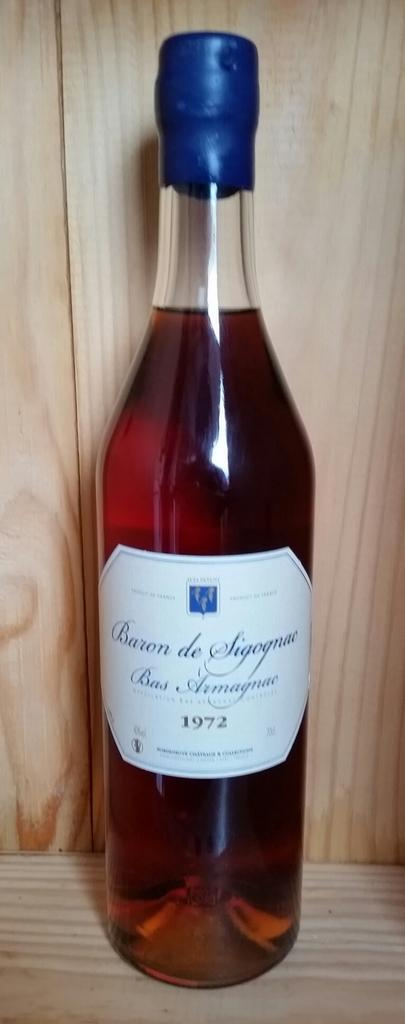<image>
Summarize the visual content of the image. A bottle of wine from 1972 has a blue cover over the cork. 